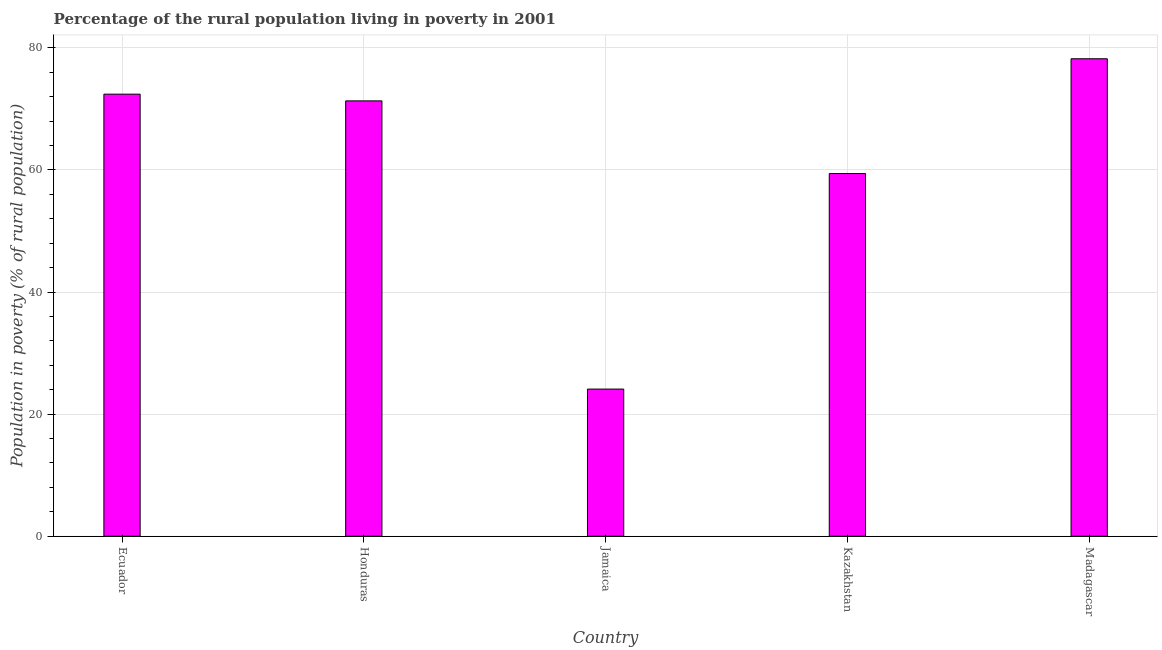Does the graph contain any zero values?
Ensure brevity in your answer.  No. What is the title of the graph?
Offer a very short reply. Percentage of the rural population living in poverty in 2001. What is the label or title of the X-axis?
Provide a succinct answer. Country. What is the label or title of the Y-axis?
Your answer should be compact. Population in poverty (% of rural population). What is the percentage of rural population living below poverty line in Honduras?
Make the answer very short. 71.3. Across all countries, what is the maximum percentage of rural population living below poverty line?
Provide a succinct answer. 78.2. Across all countries, what is the minimum percentage of rural population living below poverty line?
Offer a terse response. 24.1. In which country was the percentage of rural population living below poverty line maximum?
Your answer should be compact. Madagascar. In which country was the percentage of rural population living below poverty line minimum?
Offer a very short reply. Jamaica. What is the sum of the percentage of rural population living below poverty line?
Offer a terse response. 305.4. What is the average percentage of rural population living below poverty line per country?
Offer a terse response. 61.08. What is the median percentage of rural population living below poverty line?
Keep it short and to the point. 71.3. What is the ratio of the percentage of rural population living below poverty line in Honduras to that in Jamaica?
Offer a very short reply. 2.96. Is the percentage of rural population living below poverty line in Ecuador less than that in Honduras?
Provide a short and direct response. No. Is the difference between the percentage of rural population living below poverty line in Kazakhstan and Madagascar greater than the difference between any two countries?
Provide a succinct answer. No. Is the sum of the percentage of rural population living below poverty line in Ecuador and Jamaica greater than the maximum percentage of rural population living below poverty line across all countries?
Offer a terse response. Yes. What is the difference between the highest and the lowest percentage of rural population living below poverty line?
Provide a succinct answer. 54.1. What is the difference between two consecutive major ticks on the Y-axis?
Keep it short and to the point. 20. What is the Population in poverty (% of rural population) of Ecuador?
Ensure brevity in your answer.  72.4. What is the Population in poverty (% of rural population) of Honduras?
Offer a terse response. 71.3. What is the Population in poverty (% of rural population) in Jamaica?
Give a very brief answer. 24.1. What is the Population in poverty (% of rural population) of Kazakhstan?
Offer a very short reply. 59.4. What is the Population in poverty (% of rural population) of Madagascar?
Your answer should be very brief. 78.2. What is the difference between the Population in poverty (% of rural population) in Ecuador and Honduras?
Ensure brevity in your answer.  1.1. What is the difference between the Population in poverty (% of rural population) in Ecuador and Jamaica?
Your response must be concise. 48.3. What is the difference between the Population in poverty (% of rural population) in Honduras and Jamaica?
Your answer should be very brief. 47.2. What is the difference between the Population in poverty (% of rural population) in Honduras and Kazakhstan?
Give a very brief answer. 11.9. What is the difference between the Population in poverty (% of rural population) in Honduras and Madagascar?
Ensure brevity in your answer.  -6.9. What is the difference between the Population in poverty (% of rural population) in Jamaica and Kazakhstan?
Provide a succinct answer. -35.3. What is the difference between the Population in poverty (% of rural population) in Jamaica and Madagascar?
Ensure brevity in your answer.  -54.1. What is the difference between the Population in poverty (% of rural population) in Kazakhstan and Madagascar?
Offer a terse response. -18.8. What is the ratio of the Population in poverty (% of rural population) in Ecuador to that in Honduras?
Provide a short and direct response. 1.01. What is the ratio of the Population in poverty (% of rural population) in Ecuador to that in Jamaica?
Ensure brevity in your answer.  3. What is the ratio of the Population in poverty (% of rural population) in Ecuador to that in Kazakhstan?
Your response must be concise. 1.22. What is the ratio of the Population in poverty (% of rural population) in Ecuador to that in Madagascar?
Offer a very short reply. 0.93. What is the ratio of the Population in poverty (% of rural population) in Honduras to that in Jamaica?
Your response must be concise. 2.96. What is the ratio of the Population in poverty (% of rural population) in Honduras to that in Madagascar?
Your answer should be very brief. 0.91. What is the ratio of the Population in poverty (% of rural population) in Jamaica to that in Kazakhstan?
Give a very brief answer. 0.41. What is the ratio of the Population in poverty (% of rural population) in Jamaica to that in Madagascar?
Give a very brief answer. 0.31. What is the ratio of the Population in poverty (% of rural population) in Kazakhstan to that in Madagascar?
Keep it short and to the point. 0.76. 